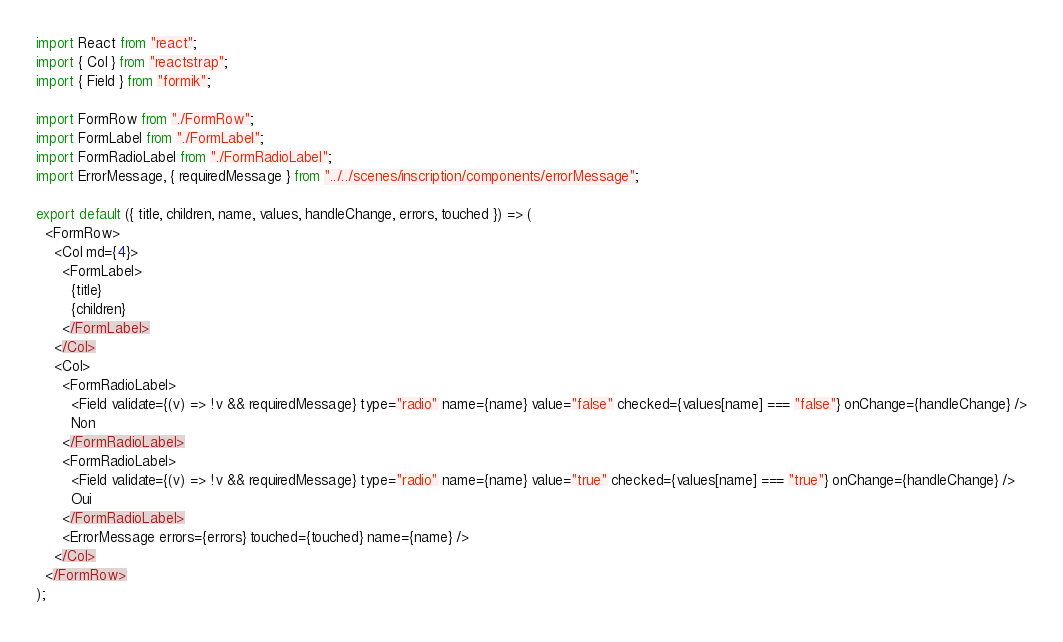Convert code to text. <code><loc_0><loc_0><loc_500><loc_500><_JavaScript_>import React from "react";
import { Col } from "reactstrap";
import { Field } from "formik";

import FormRow from "./FormRow";
import FormLabel from "./FormLabel";
import FormRadioLabel from "./FormRadioLabel";
import ErrorMessage, { requiredMessage } from "../../scenes/inscription/components/errorMessage";

export default ({ title, children, name, values, handleChange, errors, touched }) => (
  <FormRow>
    <Col md={4}>
      <FormLabel>
        {title}
        {children}
      </FormLabel>
    </Col>
    <Col>
      <FormRadioLabel>
        <Field validate={(v) => !v && requiredMessage} type="radio" name={name} value="false" checked={values[name] === "false"} onChange={handleChange} />
        Non
      </FormRadioLabel>
      <FormRadioLabel>
        <Field validate={(v) => !v && requiredMessage} type="radio" name={name} value="true" checked={values[name] === "true"} onChange={handleChange} />
        Oui
      </FormRadioLabel>
      <ErrorMessage errors={errors} touched={touched} name={name} />
    </Col>
  </FormRow>
);
</code> 